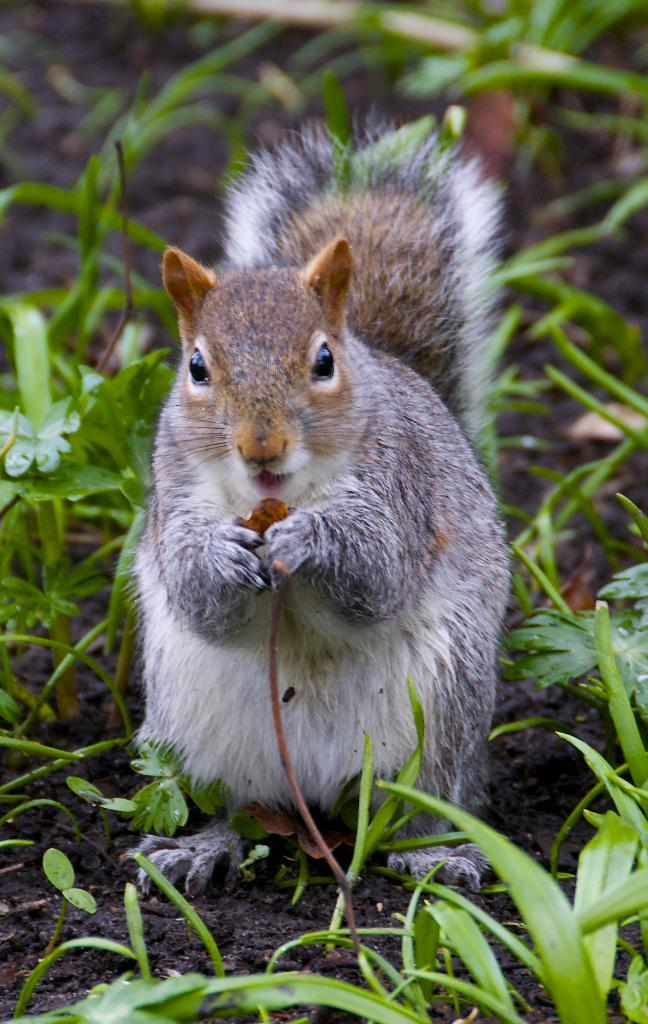What animal can be seen in the image? There is a squirrel in the image. What is the squirrel doing in the image? The squirrel is standing on the ground. What type of vegetation is visible in the image? There is grass visible in the image. What flavor of tramp can be seen in the image? There is no tramp present in the image, and therefore no flavor can be determined. 